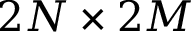Convert formula to latex. <formula><loc_0><loc_0><loc_500><loc_500>2 N \times 2 M</formula> 